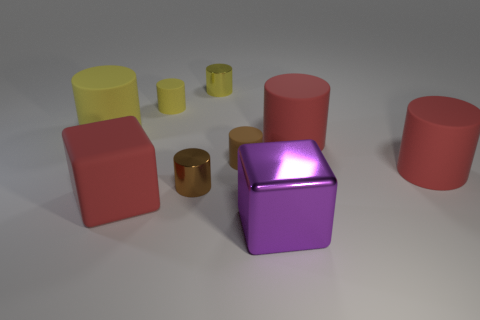Does the yellow rubber cylinder left of the red matte block have the same size as the yellow matte cylinder that is behind the big yellow thing?
Ensure brevity in your answer.  No. How many rubber cylinders are the same color as the large rubber cube?
Make the answer very short. 2. Are there more big yellow rubber things to the right of the large yellow matte thing than large purple objects?
Ensure brevity in your answer.  No. Is the tiny brown rubber object the same shape as the purple metallic object?
Ensure brevity in your answer.  No. What number of large yellow objects have the same material as the purple cube?
Give a very brief answer. 0. The brown matte object that is the same shape as the large yellow object is what size?
Offer a very short reply. Small. Does the purple object have the same size as the brown metal thing?
Your answer should be very brief. No. The red object to the left of the yellow rubber thing on the right side of the block to the left of the purple shiny block is what shape?
Offer a terse response. Cube. What is the color of the other small rubber thing that is the same shape as the brown matte thing?
Offer a terse response. Yellow. There is a red matte thing that is both in front of the brown rubber cylinder and behind the brown metal cylinder; how big is it?
Offer a very short reply. Large. 